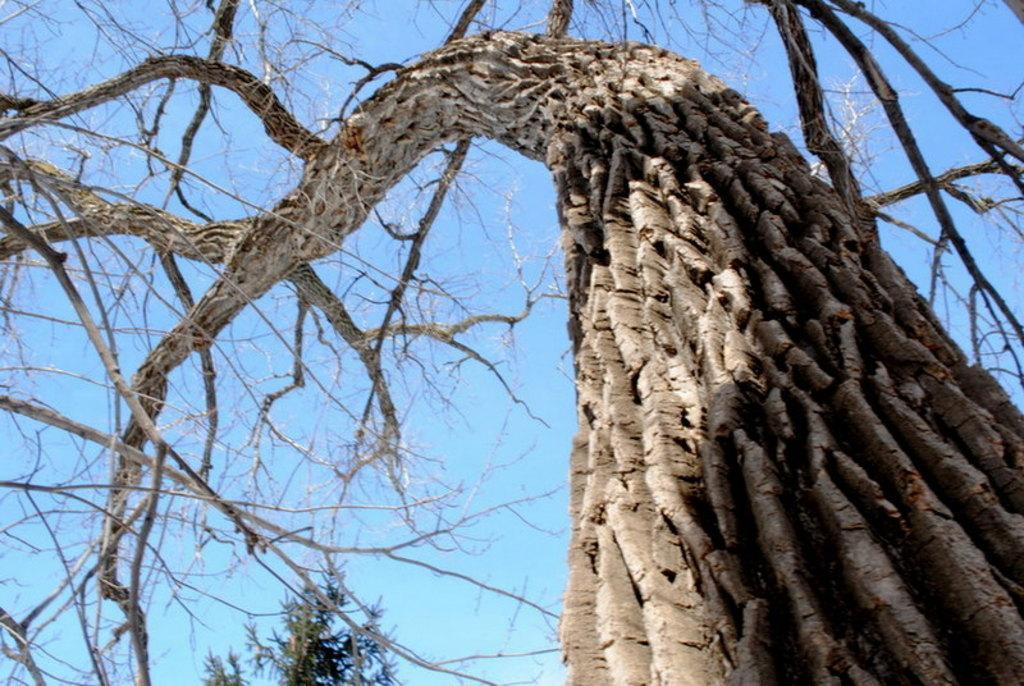How would you summarize this image in a sentence or two? In the image there is a dry tree, in the background there is a tree visible and above its sky. 